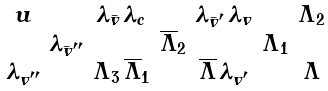<formula> <loc_0><loc_0><loc_500><loc_500>\begin{smallmatrix} u & & \lambda _ { \bar { v } } \, \lambda _ { c } & & \lambda _ { \bar { v } ^ { \prime } } \, \lambda _ { v } & & \Lambda _ { 2 } \\ \ & \lambda _ { \bar { v } ^ { \prime \prime } } & & \overline { \Lambda } _ { 2 } & & \Lambda _ { 1 } \\ \lambda _ { v ^ { \prime \prime } } & & \Lambda _ { 3 } \, \overline { \Lambda } _ { 1 } & & \overline { \Lambda } \, \lambda _ { v ^ { \prime } } & & \Lambda \end{smallmatrix}</formula> 